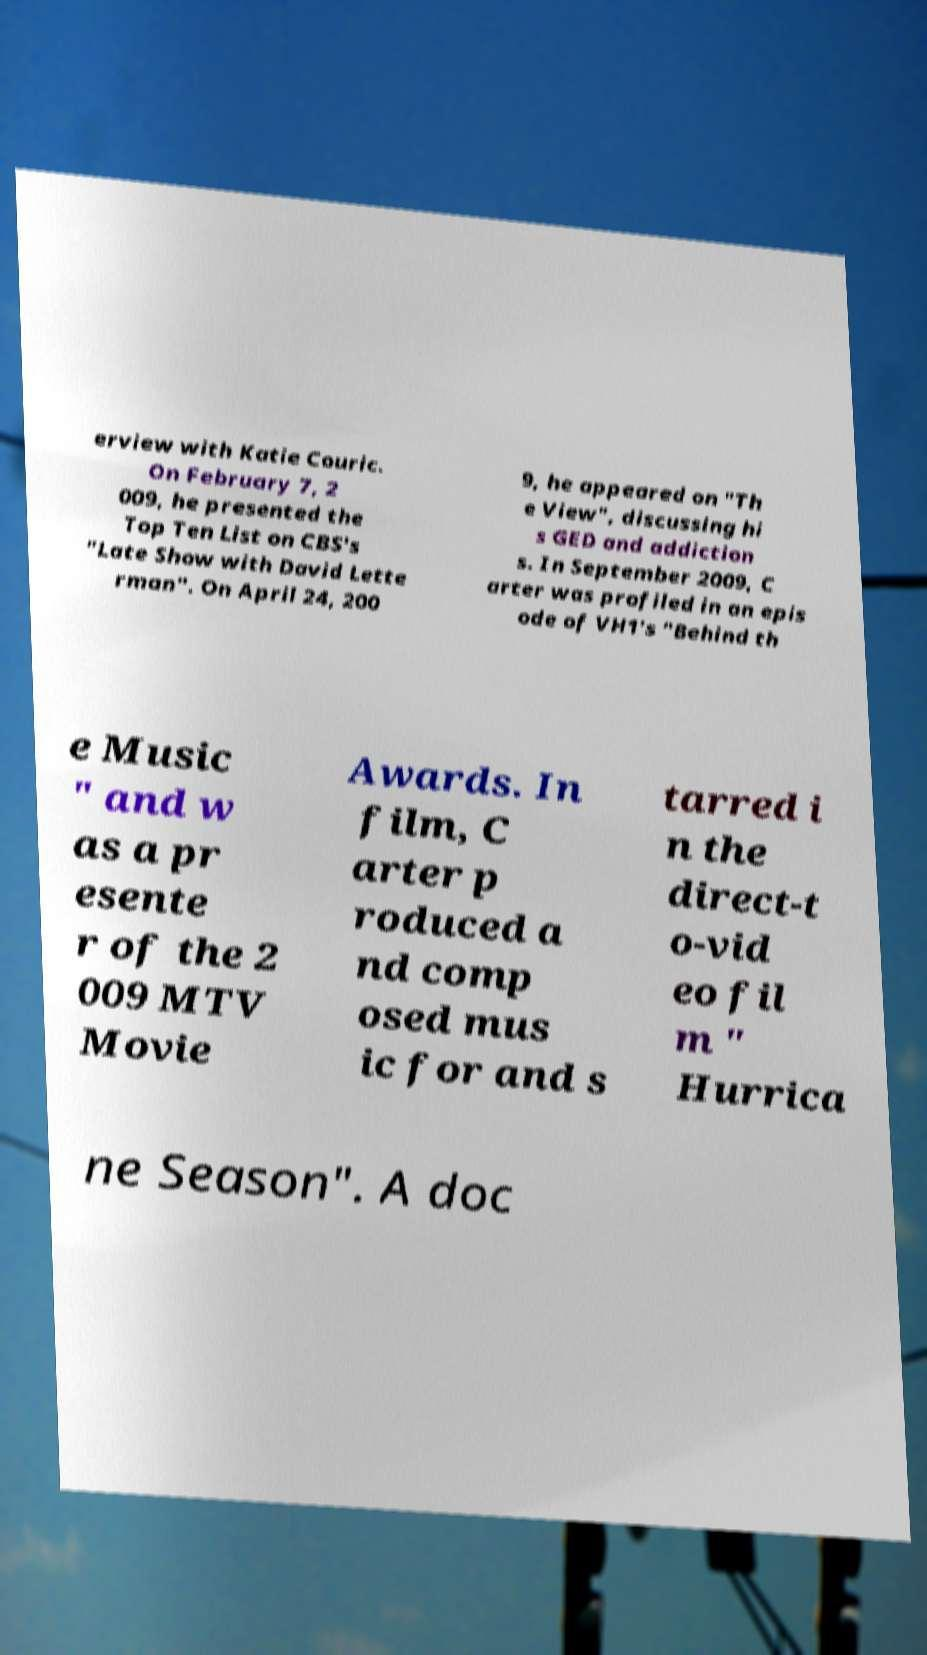Can you read and provide the text displayed in the image?This photo seems to have some interesting text. Can you extract and type it out for me? erview with Katie Couric. On February 7, 2 009, he presented the Top Ten List on CBS's "Late Show with David Lette rman". On April 24, 200 9, he appeared on "Th e View", discussing hi s GED and addiction s. In September 2009, C arter was profiled in an epis ode of VH1's "Behind th e Music " and w as a pr esente r of the 2 009 MTV Movie Awards. In film, C arter p roduced a nd comp osed mus ic for and s tarred i n the direct-t o-vid eo fil m " Hurrica ne Season". A doc 